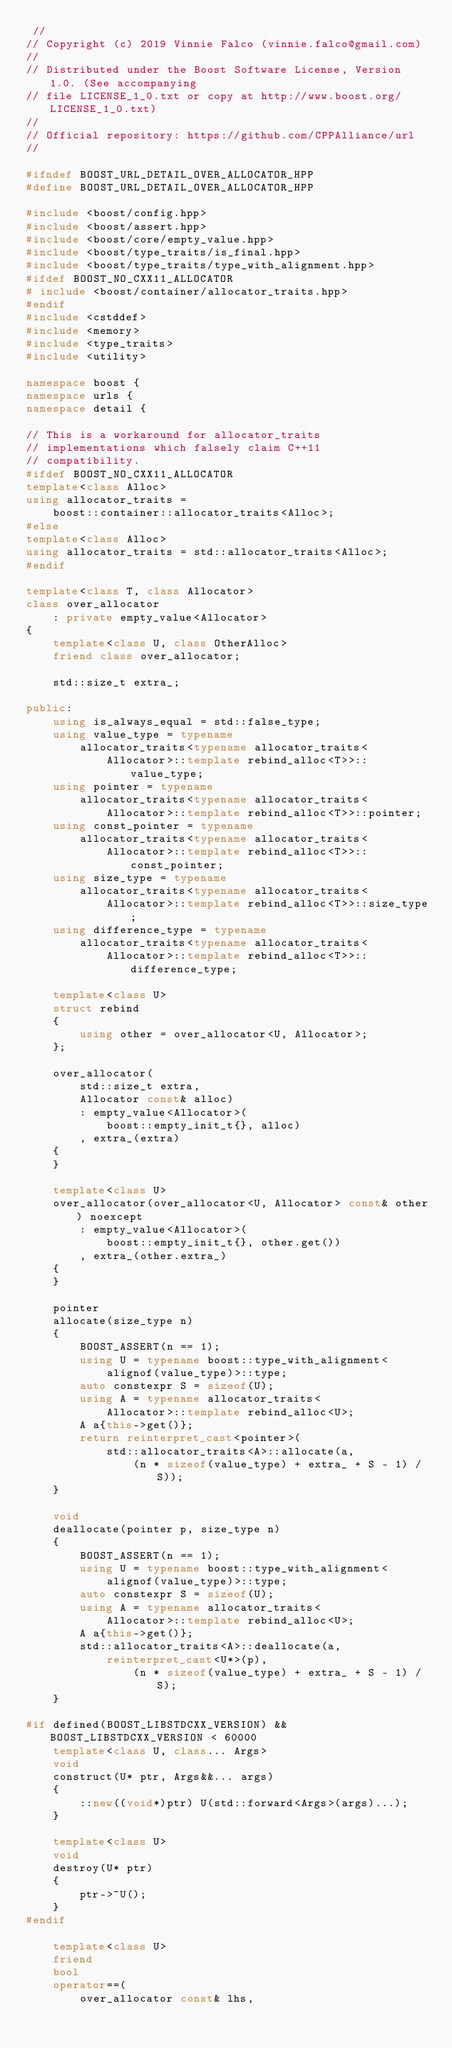<code> <loc_0><loc_0><loc_500><loc_500><_C++_> //
// Copyright (c) 2019 Vinnie Falco (vinnie.falco@gmail.com)
//
// Distributed under the Boost Software License, Version 1.0. (See accompanying
// file LICENSE_1_0.txt or copy at http://www.boost.org/LICENSE_1_0.txt)
//
// Official repository: https://github.com/CPPAlliance/url
//

#ifndef BOOST_URL_DETAIL_OVER_ALLOCATOR_HPP
#define BOOST_URL_DETAIL_OVER_ALLOCATOR_HPP

#include <boost/config.hpp>
#include <boost/assert.hpp>
#include <boost/core/empty_value.hpp>
#include <boost/type_traits/is_final.hpp>
#include <boost/type_traits/type_with_alignment.hpp>
#ifdef BOOST_NO_CXX11_ALLOCATOR
# include <boost/container/allocator_traits.hpp>
#endif
#include <cstddef>
#include <memory>
#include <type_traits>
#include <utility>

namespace boost {
namespace urls {
namespace detail {

// This is a workaround for allocator_traits
// implementations which falsely claim C++11
// compatibility.
#ifdef BOOST_NO_CXX11_ALLOCATOR
template<class Alloc>
using allocator_traits =
    boost::container::allocator_traits<Alloc>;
#else
template<class Alloc>
using allocator_traits = std::allocator_traits<Alloc>;
#endif

template<class T, class Allocator>
class over_allocator
    : private empty_value<Allocator>
{
    template<class U, class OtherAlloc>
    friend class over_allocator;

    std::size_t extra_;

public:
    using is_always_equal = std::false_type;
    using value_type = typename
        allocator_traits<typename allocator_traits<
            Allocator>::template rebind_alloc<T>>::value_type;
    using pointer = typename
        allocator_traits<typename allocator_traits<
            Allocator>::template rebind_alloc<T>>::pointer;
    using const_pointer = typename
        allocator_traits<typename allocator_traits<
            Allocator>::template rebind_alloc<T>>::const_pointer;
    using size_type = typename
        allocator_traits<typename allocator_traits<
            Allocator>::template rebind_alloc<T>>::size_type;
    using difference_type = typename
        allocator_traits<typename allocator_traits<
            Allocator>::template rebind_alloc<T>>::difference_type;

    template<class U>
    struct rebind
    {
        using other = over_allocator<U, Allocator>;
    };

    over_allocator(
        std::size_t extra,
        Allocator const& alloc)
        : empty_value<Allocator>(
            boost::empty_init_t{}, alloc)
        , extra_(extra)
    {
    }

    template<class U>
    over_allocator(over_allocator<U, Allocator> const& other) noexcept
        : empty_value<Allocator>(
            boost::empty_init_t{}, other.get())
        , extra_(other.extra_)
    {
    }

    pointer
    allocate(size_type n)
    {
        BOOST_ASSERT(n == 1);
        using U = typename boost::type_with_alignment<
            alignof(value_type)>::type;
        auto constexpr S = sizeof(U);
        using A = typename allocator_traits<
            Allocator>::template rebind_alloc<U>;
        A a{this->get()};
        return reinterpret_cast<pointer>(
            std::allocator_traits<A>::allocate(a,
                (n * sizeof(value_type) + extra_ + S - 1) / S));
    }

    void
    deallocate(pointer p, size_type n)
    {
        BOOST_ASSERT(n == 1);
        using U = typename boost::type_with_alignment<
            alignof(value_type)>::type;
        auto constexpr S = sizeof(U);
        using A = typename allocator_traits<
            Allocator>::template rebind_alloc<U>;
        A a{this->get()};
        std::allocator_traits<A>::deallocate(a,
            reinterpret_cast<U*>(p),
                (n * sizeof(value_type) + extra_ + S - 1) / S);
    }

#if defined(BOOST_LIBSTDCXX_VERSION) && BOOST_LIBSTDCXX_VERSION < 60000
    template<class U, class... Args>
    void
    construct(U* ptr, Args&&... args)
    {
        ::new((void*)ptr) U(std::forward<Args>(args)...);
    }

    template<class U>
    void
    destroy(U* ptr)
    {
        ptr->~U();
    }
#endif

    template<class U>
    friend
    bool
    operator==(
        over_allocator const& lhs,</code> 